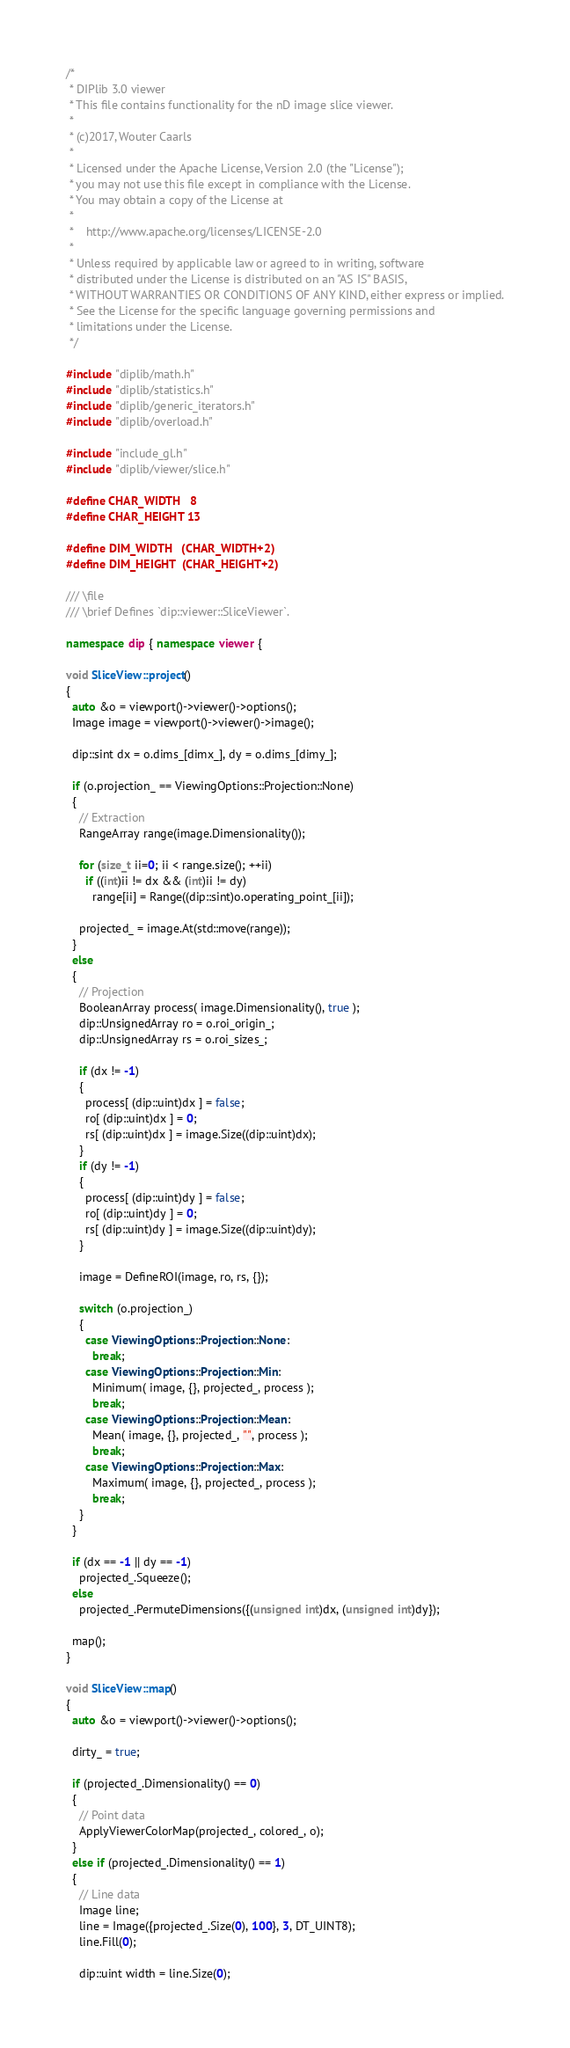Convert code to text. <code><loc_0><loc_0><loc_500><loc_500><_C++_>/*
 * DIPlib 3.0 viewer
 * This file contains functionality for the nD image slice viewer.
 *
 * (c)2017, Wouter Caarls
 *
 * Licensed under the Apache License, Version 2.0 (the "License");
 * you may not use this file except in compliance with the License.
 * You may obtain a copy of the License at
 *
 *    http://www.apache.org/licenses/LICENSE-2.0
 *
 * Unless required by applicable law or agreed to in writing, software
 * distributed under the License is distributed on an "AS IS" BASIS,
 * WITHOUT WARRANTIES OR CONDITIONS OF ANY KIND, either express or implied.
 * See the License for the specific language governing permissions and
 * limitations under the License.
 */

#include "diplib/math.h"
#include "diplib/statistics.h"
#include "diplib/generic_iterators.h"
#include "diplib/overload.h"

#include "include_gl.h"
#include "diplib/viewer/slice.h"

#define CHAR_WIDTH   8
#define CHAR_HEIGHT 13

#define DIM_WIDTH   (CHAR_WIDTH+2)
#define DIM_HEIGHT  (CHAR_HEIGHT+2)

/// \file
/// \brief Defines `dip::viewer::SliceViewer`.

namespace dip { namespace viewer {

void SliceView::project()
{
  auto &o = viewport()->viewer()->options();
  Image image = viewport()->viewer()->image();
  
  dip::sint dx = o.dims_[dimx_], dy = o.dims_[dimy_];
  
  if (o.projection_ == ViewingOptions::Projection::None)
  {
    // Extraction
    RangeArray range(image.Dimensionality());
    
    for (size_t ii=0; ii < range.size(); ++ii)
      if ((int)ii != dx && (int)ii != dy)
        range[ii] = Range((dip::sint)o.operating_point_[ii]);
        
    projected_ = image.At(std::move(range));
  }
  else
  {
    // Projection
    BooleanArray process( image.Dimensionality(), true );
    dip::UnsignedArray ro = o.roi_origin_;
    dip::UnsignedArray rs = o.roi_sizes_;
    
    if (dx != -1)
    {
      process[ (dip::uint)dx ] = false;
      ro[ (dip::uint)dx ] = 0;
      rs[ (dip::uint)dx ] = image.Size((dip::uint)dx);
    }
    if (dy != -1)
    {
      process[ (dip::uint)dy ] = false;
      ro[ (dip::uint)dy ] = 0;
      rs[ (dip::uint)dy ] = image.Size((dip::uint)dy);
    }
  
    image = DefineROI(image, ro, rs, {});
    
    switch (o.projection_)
    {
      case ViewingOptions::Projection::None:
        break;
      case ViewingOptions::Projection::Min:
        Minimum( image, {}, projected_, process );
        break;
      case ViewingOptions::Projection::Mean:
        Mean( image, {}, projected_, "", process );
        break;
      case ViewingOptions::Projection::Max:
        Maximum( image, {}, projected_, process );
        break;
    }
  }
  
  if (dx == -1 || dy == -1)
    projected_.Squeeze();
  else
    projected_.PermuteDimensions({(unsigned int)dx, (unsigned int)dy});
    
  map();
}

void SliceView::map()
{
  auto &o = viewport()->viewer()->options();
  
  dirty_ = true;
  
  if (projected_.Dimensionality() == 0)
  {
    // Point data
    ApplyViewerColorMap(projected_, colored_, o);
  }
  else if (projected_.Dimensionality() == 1)
  {
    // Line data
    Image line;
    line = Image({projected_.Size(0), 100}, 3, DT_UINT8);
    line.Fill(0);
    
    dip::uint width = line.Size(0);</code> 